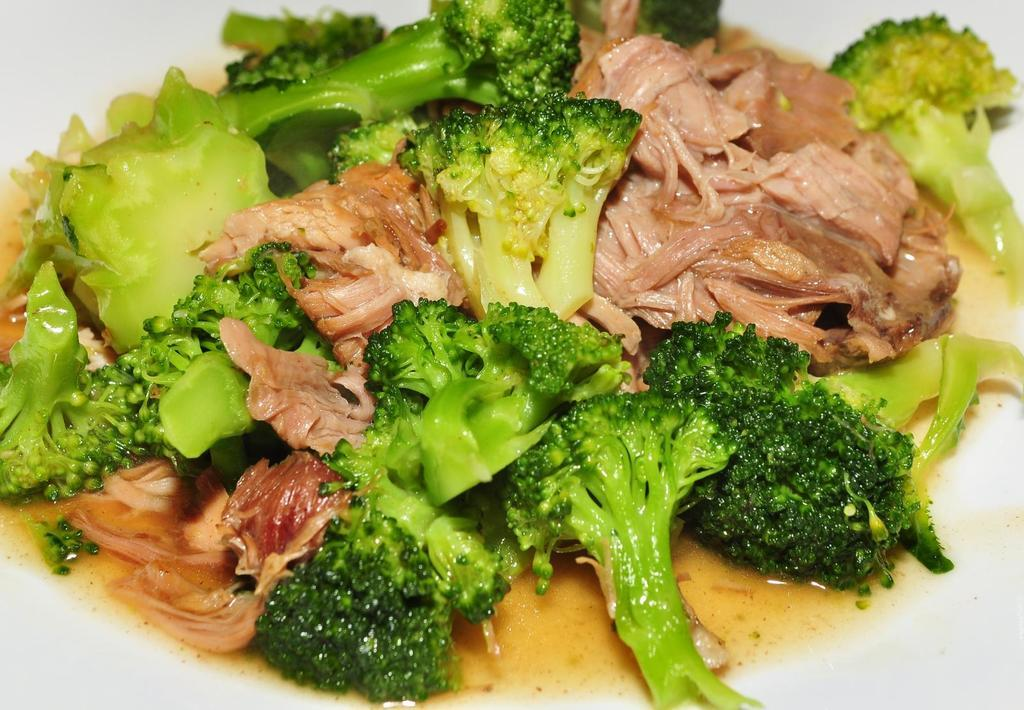What is the main subject of the image? There is a food item in the image. How many plantations can be seen in the image? There are no plantations present in the image; it features a food item. What type of road is visible in the image? There is no road visible in the image; it features a food item. 